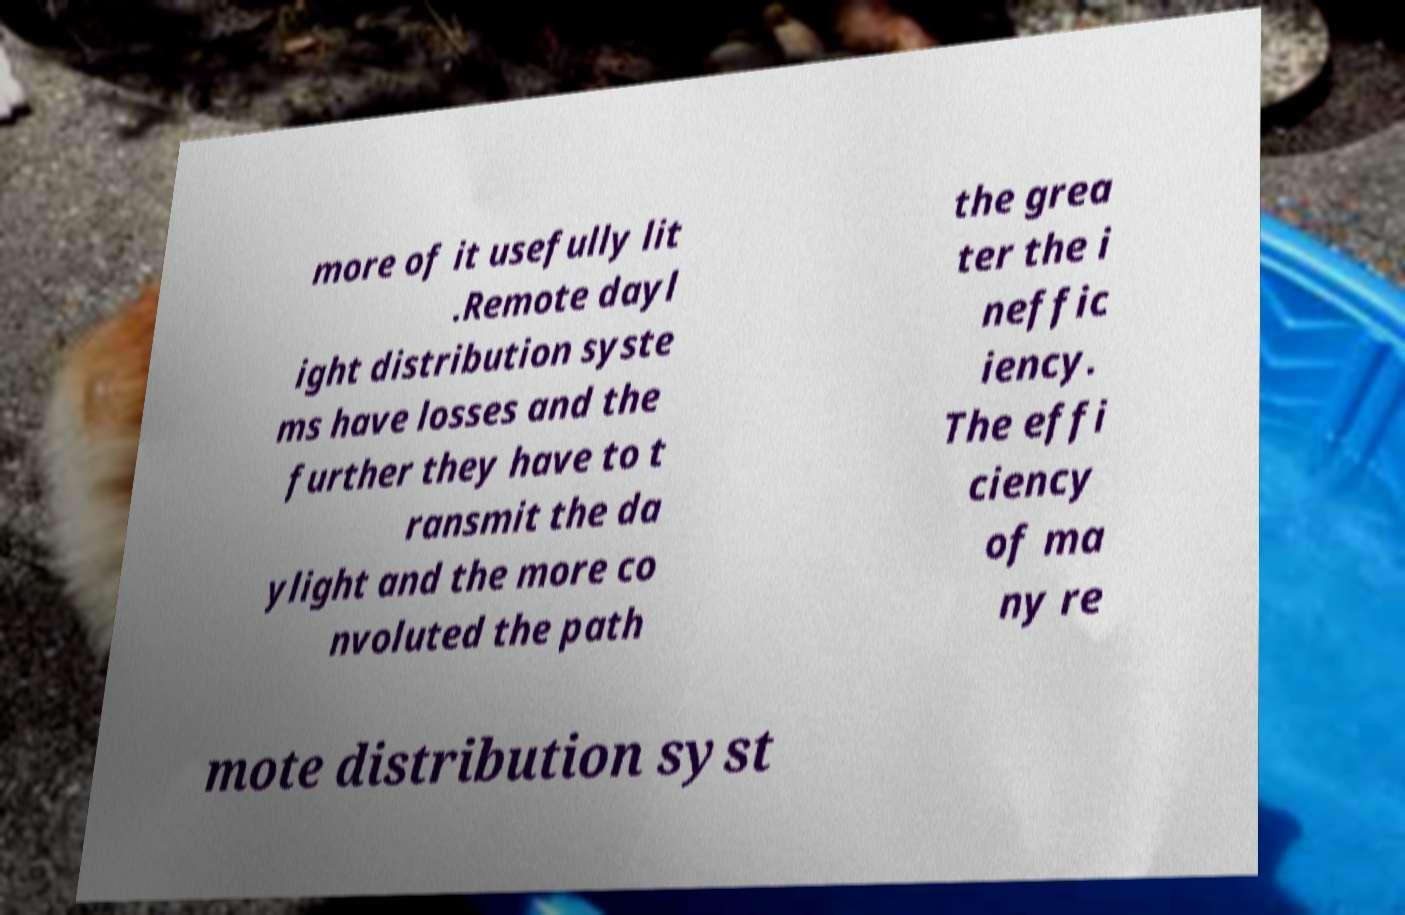There's text embedded in this image that I need extracted. Can you transcribe it verbatim? more of it usefully lit .Remote dayl ight distribution syste ms have losses and the further they have to t ransmit the da ylight and the more co nvoluted the path the grea ter the i neffic iency. The effi ciency of ma ny re mote distribution syst 